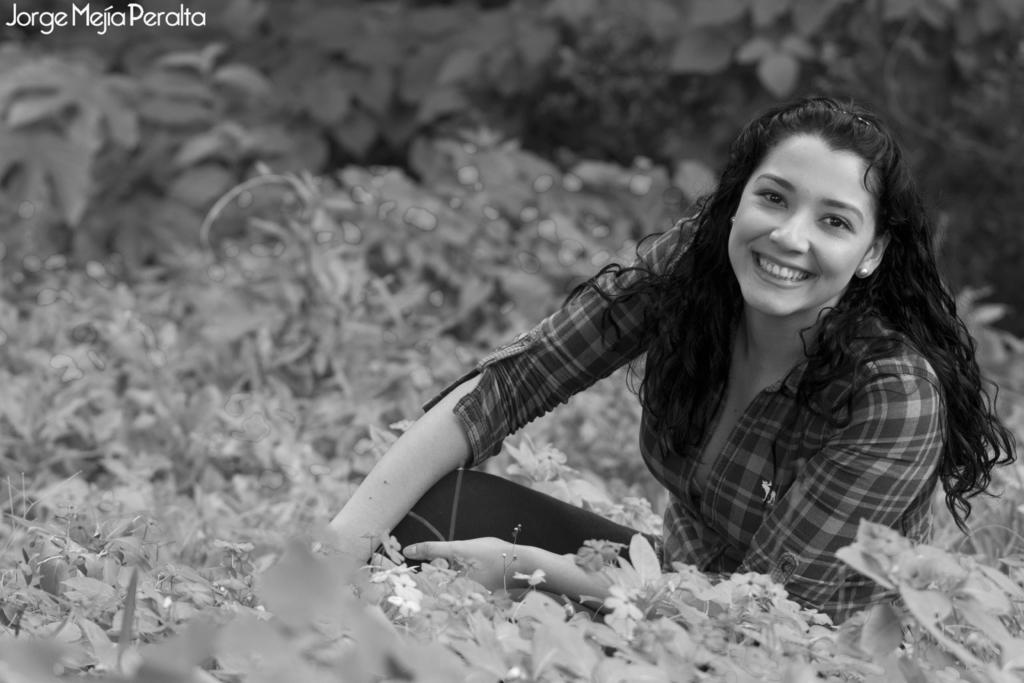What is the woman in the image doing? The woman is sitting in the image. What is the woman's facial expression? The woman is smiling. What can be seen in the background of the image? There are plants in the background of the image. What type of plants are present? The plants have flowers on them. Where is the text located in the image? The text is in the top left corner of the image. How are the cows distributed in the image? There are no cows present in the image. What direction is the wind blowing in the image? There is no indication of wind in the image. 